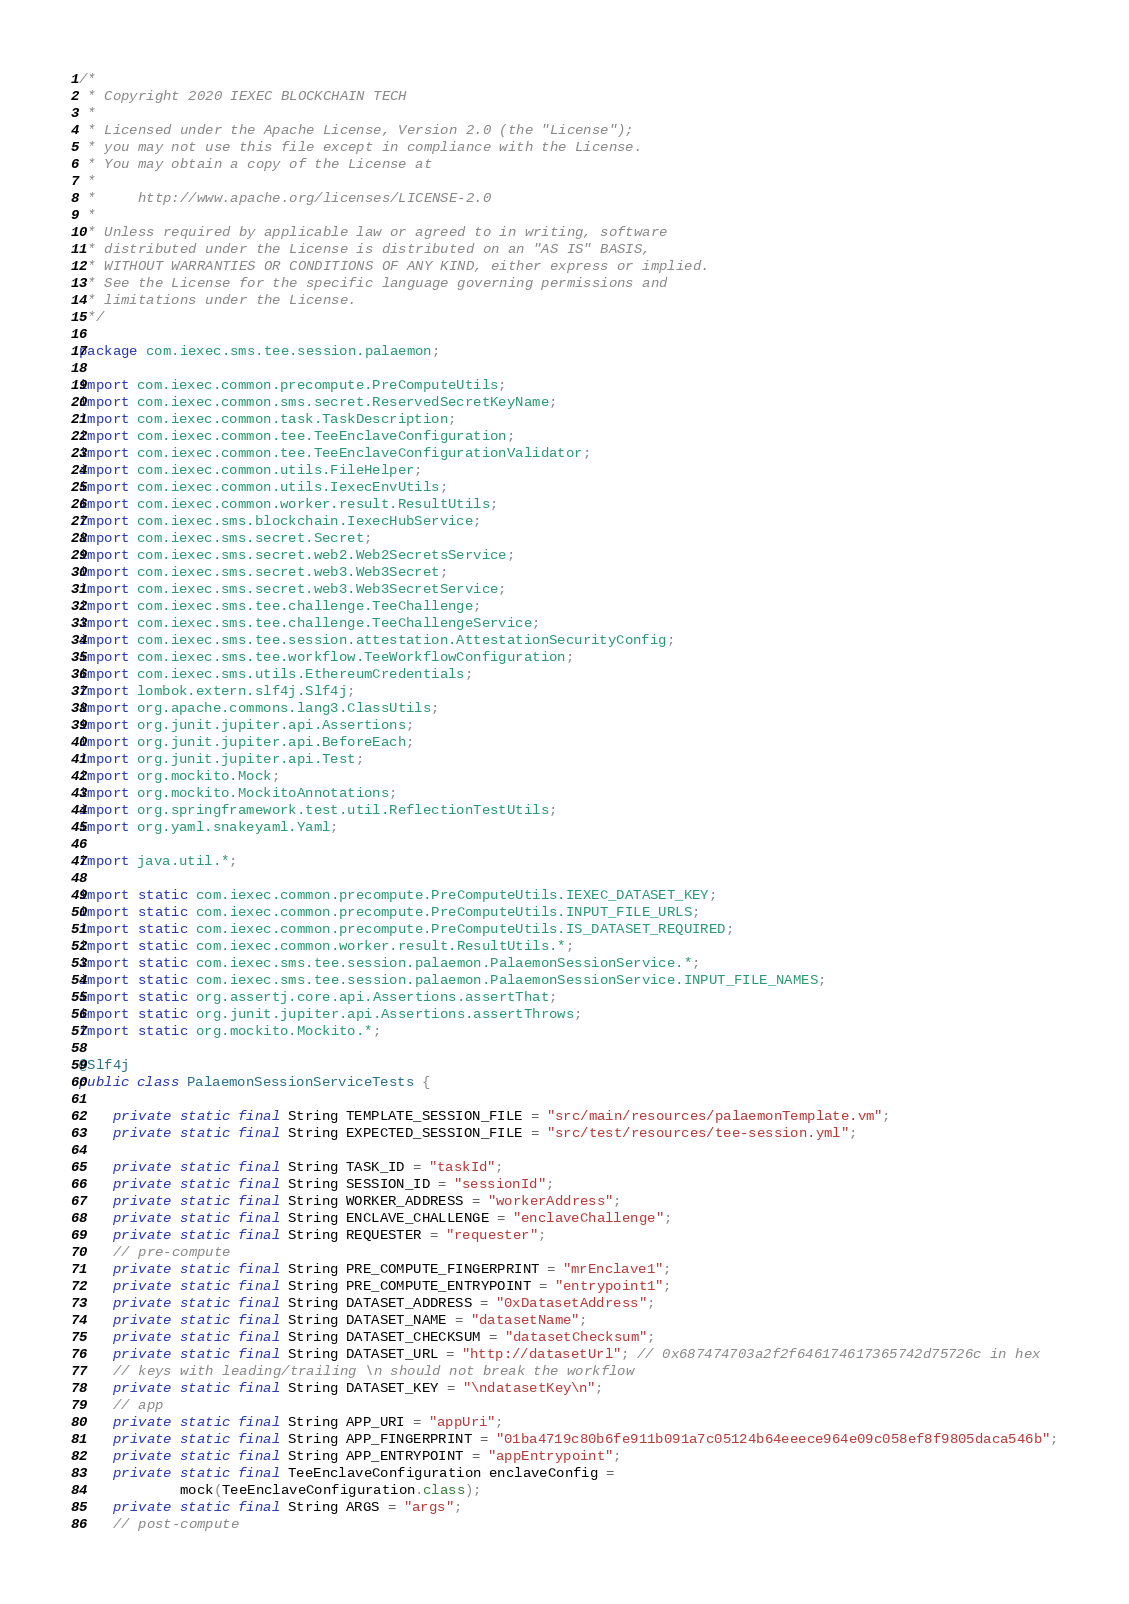Convert code to text. <code><loc_0><loc_0><loc_500><loc_500><_Java_>/*
 * Copyright 2020 IEXEC BLOCKCHAIN TECH
 *
 * Licensed under the Apache License, Version 2.0 (the "License");
 * you may not use this file except in compliance with the License.
 * You may obtain a copy of the License at
 *
 *     http://www.apache.org/licenses/LICENSE-2.0
 *
 * Unless required by applicable law or agreed to in writing, software
 * distributed under the License is distributed on an "AS IS" BASIS,
 * WITHOUT WARRANTIES OR CONDITIONS OF ANY KIND, either express or implied.
 * See the License for the specific language governing permissions and
 * limitations under the License.
 */

package com.iexec.sms.tee.session.palaemon;

import com.iexec.common.precompute.PreComputeUtils;
import com.iexec.common.sms.secret.ReservedSecretKeyName;
import com.iexec.common.task.TaskDescription;
import com.iexec.common.tee.TeeEnclaveConfiguration;
import com.iexec.common.tee.TeeEnclaveConfigurationValidator;
import com.iexec.common.utils.FileHelper;
import com.iexec.common.utils.IexecEnvUtils;
import com.iexec.common.worker.result.ResultUtils;
import com.iexec.sms.blockchain.IexecHubService;
import com.iexec.sms.secret.Secret;
import com.iexec.sms.secret.web2.Web2SecretsService;
import com.iexec.sms.secret.web3.Web3Secret;
import com.iexec.sms.secret.web3.Web3SecretService;
import com.iexec.sms.tee.challenge.TeeChallenge;
import com.iexec.sms.tee.challenge.TeeChallengeService;
import com.iexec.sms.tee.session.attestation.AttestationSecurityConfig;
import com.iexec.sms.tee.workflow.TeeWorkflowConfiguration;
import com.iexec.sms.utils.EthereumCredentials;
import lombok.extern.slf4j.Slf4j;
import org.apache.commons.lang3.ClassUtils;
import org.junit.jupiter.api.Assertions;
import org.junit.jupiter.api.BeforeEach;
import org.junit.jupiter.api.Test;
import org.mockito.Mock;
import org.mockito.MockitoAnnotations;
import org.springframework.test.util.ReflectionTestUtils;
import org.yaml.snakeyaml.Yaml;

import java.util.*;

import static com.iexec.common.precompute.PreComputeUtils.IEXEC_DATASET_KEY;
import static com.iexec.common.precompute.PreComputeUtils.INPUT_FILE_URLS;
import static com.iexec.common.precompute.PreComputeUtils.IS_DATASET_REQUIRED;
import static com.iexec.common.worker.result.ResultUtils.*;
import static com.iexec.sms.tee.session.palaemon.PalaemonSessionService.*;
import static com.iexec.sms.tee.session.palaemon.PalaemonSessionService.INPUT_FILE_NAMES;
import static org.assertj.core.api.Assertions.assertThat;
import static org.junit.jupiter.api.Assertions.assertThrows;
import static org.mockito.Mockito.*;

@Slf4j
public class PalaemonSessionServiceTests {

    private static final String TEMPLATE_SESSION_FILE = "src/main/resources/palaemonTemplate.vm";
    private static final String EXPECTED_SESSION_FILE = "src/test/resources/tee-session.yml";

    private static final String TASK_ID = "taskId";
    private static final String SESSION_ID = "sessionId";
    private static final String WORKER_ADDRESS = "workerAddress";
    private static final String ENCLAVE_CHALLENGE = "enclaveChallenge";
    private static final String REQUESTER = "requester";
    // pre-compute
    private static final String PRE_COMPUTE_FINGERPRINT = "mrEnclave1";
    private static final String PRE_COMPUTE_ENTRYPOINT = "entrypoint1";
    private static final String DATASET_ADDRESS = "0xDatasetAddress";
    private static final String DATASET_NAME = "datasetName";
    private static final String DATASET_CHECKSUM = "datasetChecksum";
    private static final String DATASET_URL = "http://datasetUrl"; // 0x687474703a2f2f646174617365742d75726c in hex
    // keys with leading/trailing \n should not break the workflow
    private static final String DATASET_KEY = "\ndatasetKey\n";
    // app
    private static final String APP_URI = "appUri";
    private static final String APP_FINGERPRINT = "01ba4719c80b6fe911b091a7c05124b64eeece964e09c058ef8f9805daca546b";
    private static final String APP_ENTRYPOINT = "appEntrypoint";
    private static final TeeEnclaveConfiguration enclaveConfig =
            mock(TeeEnclaveConfiguration.class);
    private static final String ARGS = "args";
    // post-compute</code> 